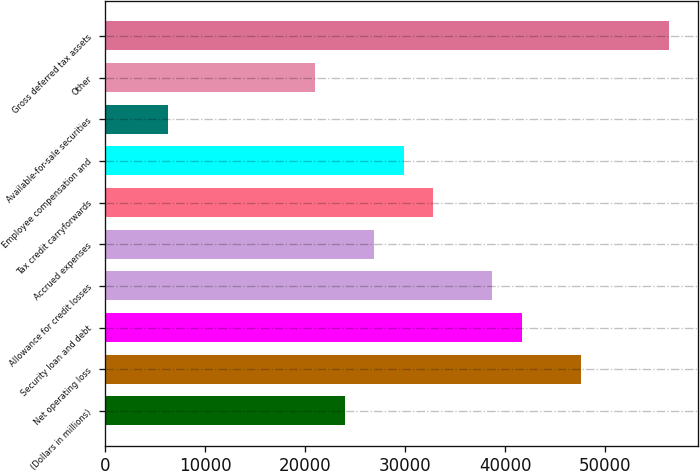<chart> <loc_0><loc_0><loc_500><loc_500><bar_chart><fcel>(Dollars in millions)<fcel>Net operating loss<fcel>Security loan and debt<fcel>Allowance for credit losses<fcel>Accrued expenses<fcel>Tax credit carryforwards<fcel>Employee compensation and<fcel>Available-for-sale securities<fcel>Other<fcel>Gross deferred tax assets<nl><fcel>23953.4<fcel>47551.8<fcel>41652.2<fcel>38702.4<fcel>26903.2<fcel>32802.8<fcel>29853<fcel>6254.6<fcel>21003.6<fcel>56401.2<nl></chart> 